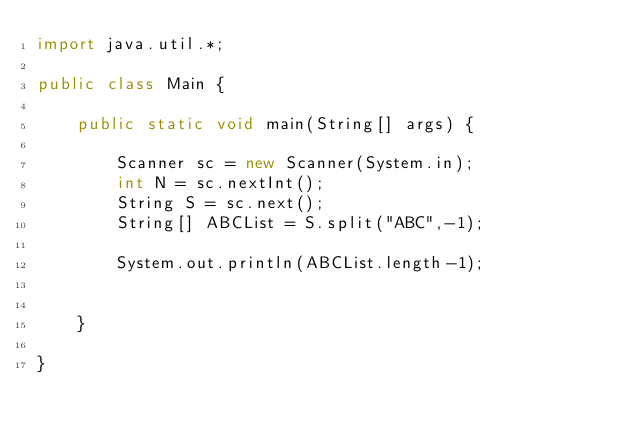Convert code to text. <code><loc_0><loc_0><loc_500><loc_500><_Java_>import java.util.*;

public class Main {

    public static void main(String[] args) {

        Scanner sc = new Scanner(System.in);
        int N = sc.nextInt();
        String S = sc.next();
        String[] ABCList = S.split("ABC",-1);

        System.out.println(ABCList.length-1);


    }

}
</code> 